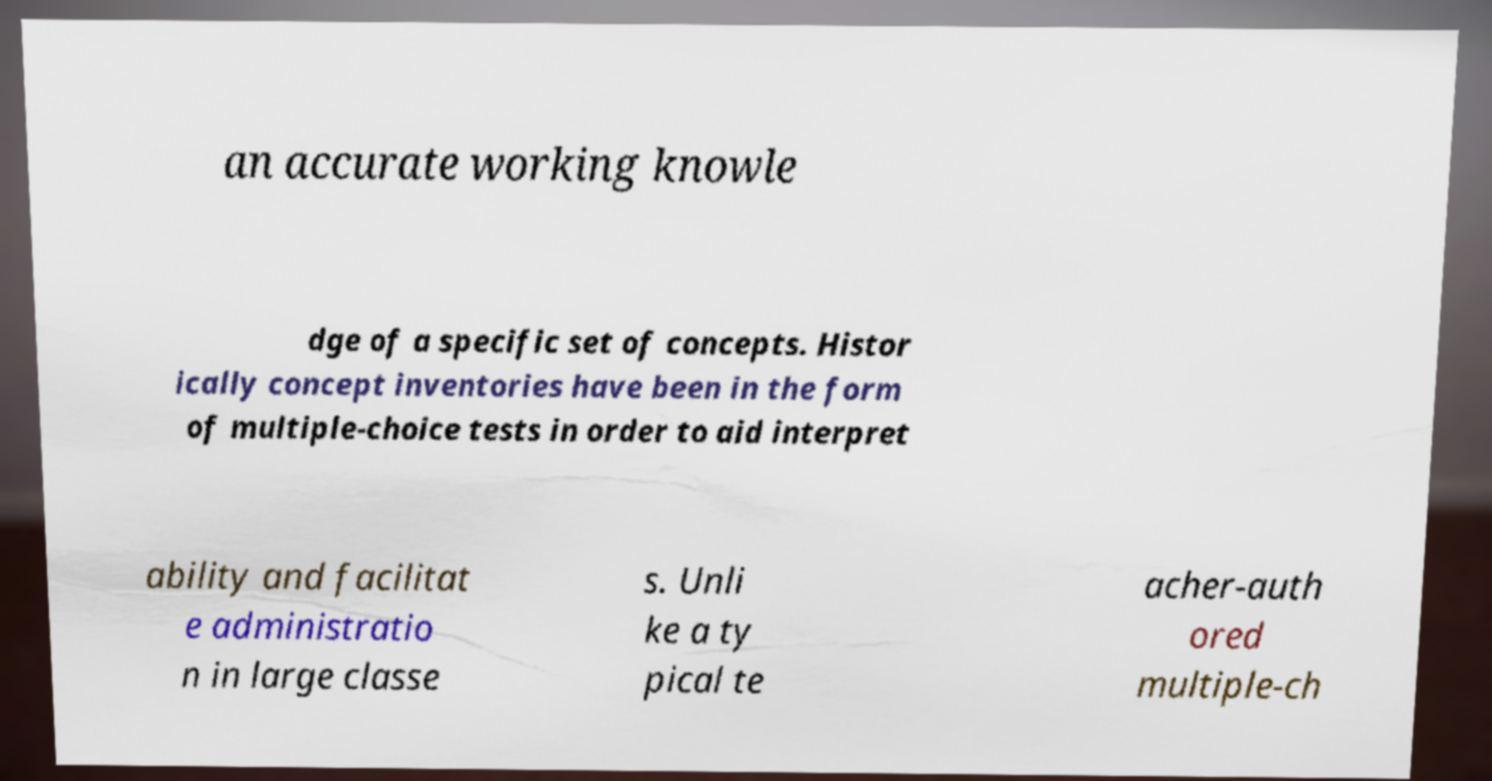Could you extract and type out the text from this image? an accurate working knowle dge of a specific set of concepts. Histor ically concept inventories have been in the form of multiple-choice tests in order to aid interpret ability and facilitat e administratio n in large classe s. Unli ke a ty pical te acher-auth ored multiple-ch 